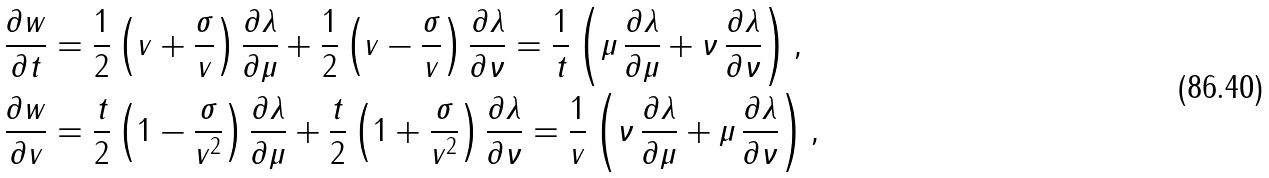Convert formula to latex. <formula><loc_0><loc_0><loc_500><loc_500>\frac { \partial w } { \partial t } & = \frac { 1 } { 2 } \left ( v + \frac { \sigma } { v } \right ) \frac { \partial \lambda } { \partial \mu } + \frac { 1 } { 2 } \left ( v - \frac { \sigma } { v } \right ) \frac { \partial \lambda } { \partial \nu } = \frac { 1 } { t } \left ( \mu \, \frac { \partial \lambda } { \partial \mu } + \nu \, \frac { \partial \lambda } { \partial \nu } \right ) , \\ \frac { \partial w } { \partial v } & = \frac { t } { 2 } \left ( 1 - \frac { \sigma } { v ^ { 2 } } \right ) \frac { \partial \lambda } { \partial \mu } + \frac { t } { 2 } \left ( 1 + \frac { \sigma } { v ^ { 2 } } \right ) \frac { \partial \lambda } { \partial \nu } = \frac { 1 } { v } \left ( \nu \, \frac { \partial \lambda } { \partial \mu } + \mu \, \frac { \partial \lambda } { \partial \nu } \right ) ,</formula> 